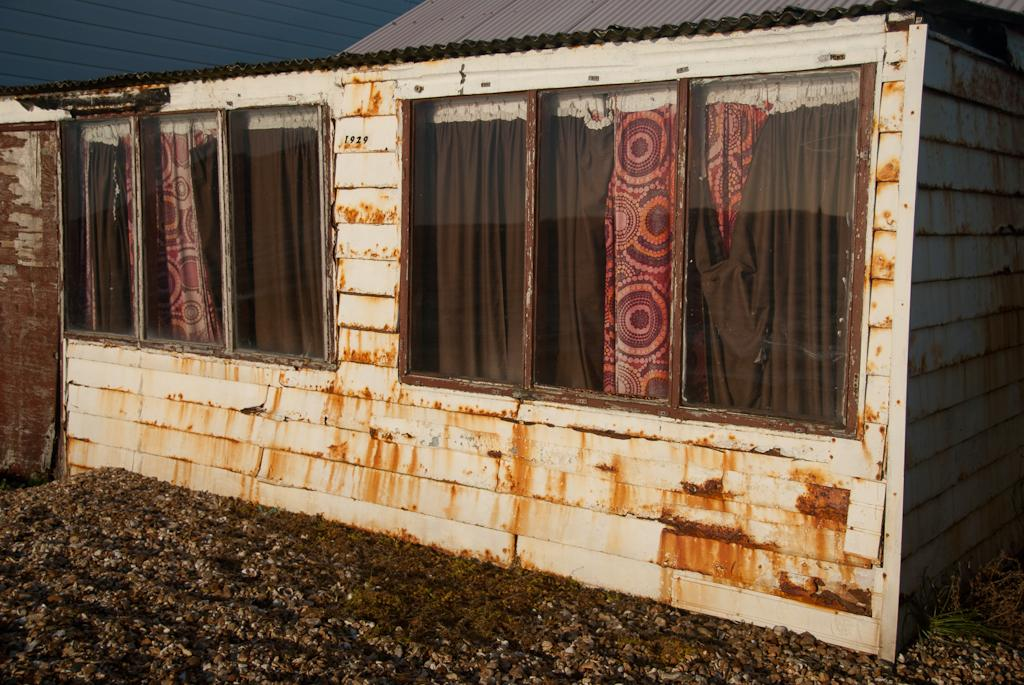What type of structure is in the image? There is a building in the image. What material is used for the building's wall? The building has a brick wall. What architectural feature can be seen on the building? The building has windows. What can be seen inside the building through the windows? Curtains are visible through the windows. What type of cub can be seen playing with a request on the table in the image? There is no cub or table present in the image; it features a building with a brick wall, windows, and curtains. 